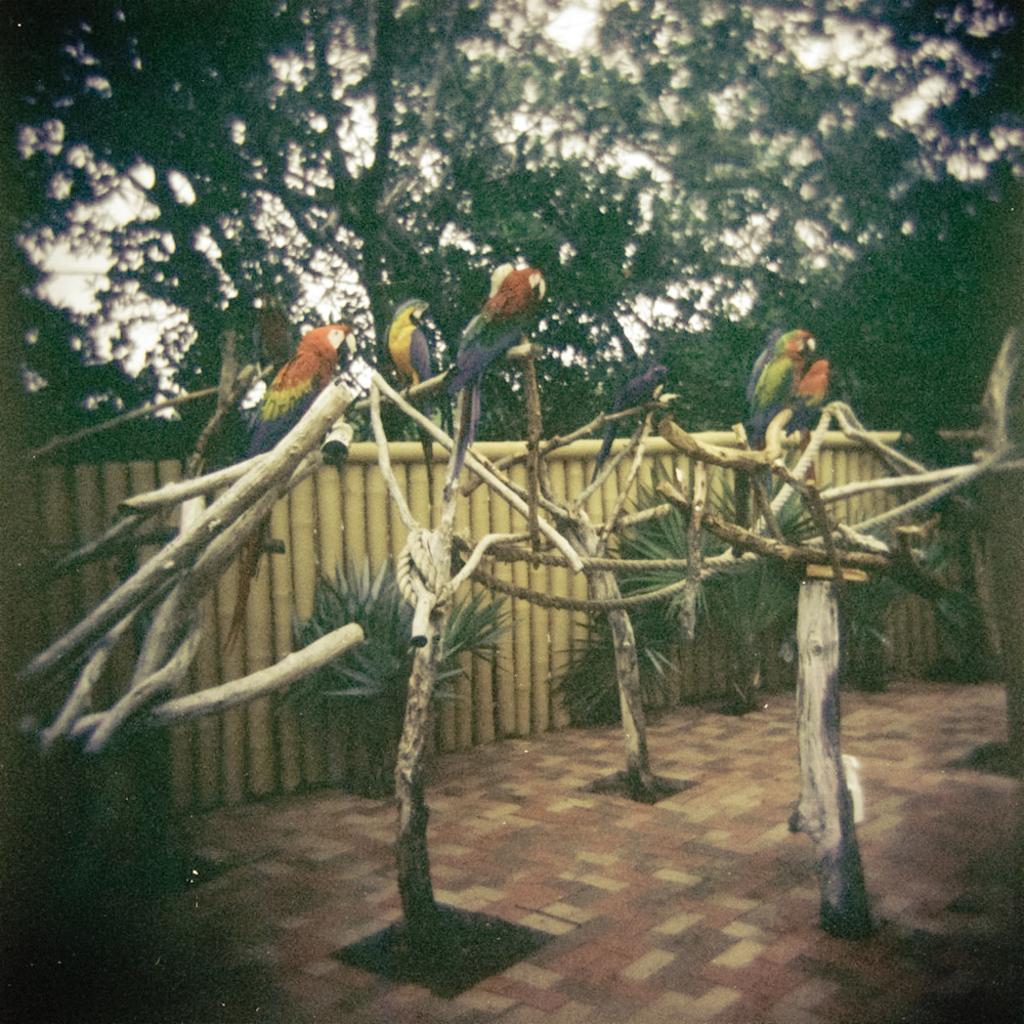In one or two sentences, can you explain what this image depicts? In this image we can see few birds on the tree trunks and rope to the trunks there are few plants, a wooden fence and tree in the background. 